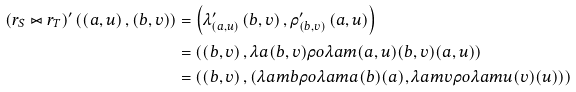<formula> <loc_0><loc_0><loc_500><loc_500>\left ( r _ { S } \bowtie r _ { T } \right ) ^ { \prime } \left ( \left ( a , u \right ) , \left ( b , v \right ) \right ) & = \left ( \lambda ^ { \prime } _ { \left ( a , u \right ) } \left ( b , v \right ) , \rho ^ { \prime } _ { \left ( b , v \right ) } \left ( a , u \right ) \right ) \\ & = \left ( \left ( b , v \right ) , \lambda a { \left ( b , v \right ) } { \rho o { \lambda a m { \left ( a , u \right ) } { \left ( b , v \right ) } } { \left ( a , u \right ) } } \right ) \\ & = \left ( \left ( b , v \right ) , \left ( \lambda a m { b } { \rho o { \lambda a m { a } { \left ( b \right ) } } { \left ( a \right ) } } , \lambda a m { v } { \rho o { \lambda a m { u } { \left ( v \right ) } } { \left ( u \right ) } } \right ) \right )</formula> 